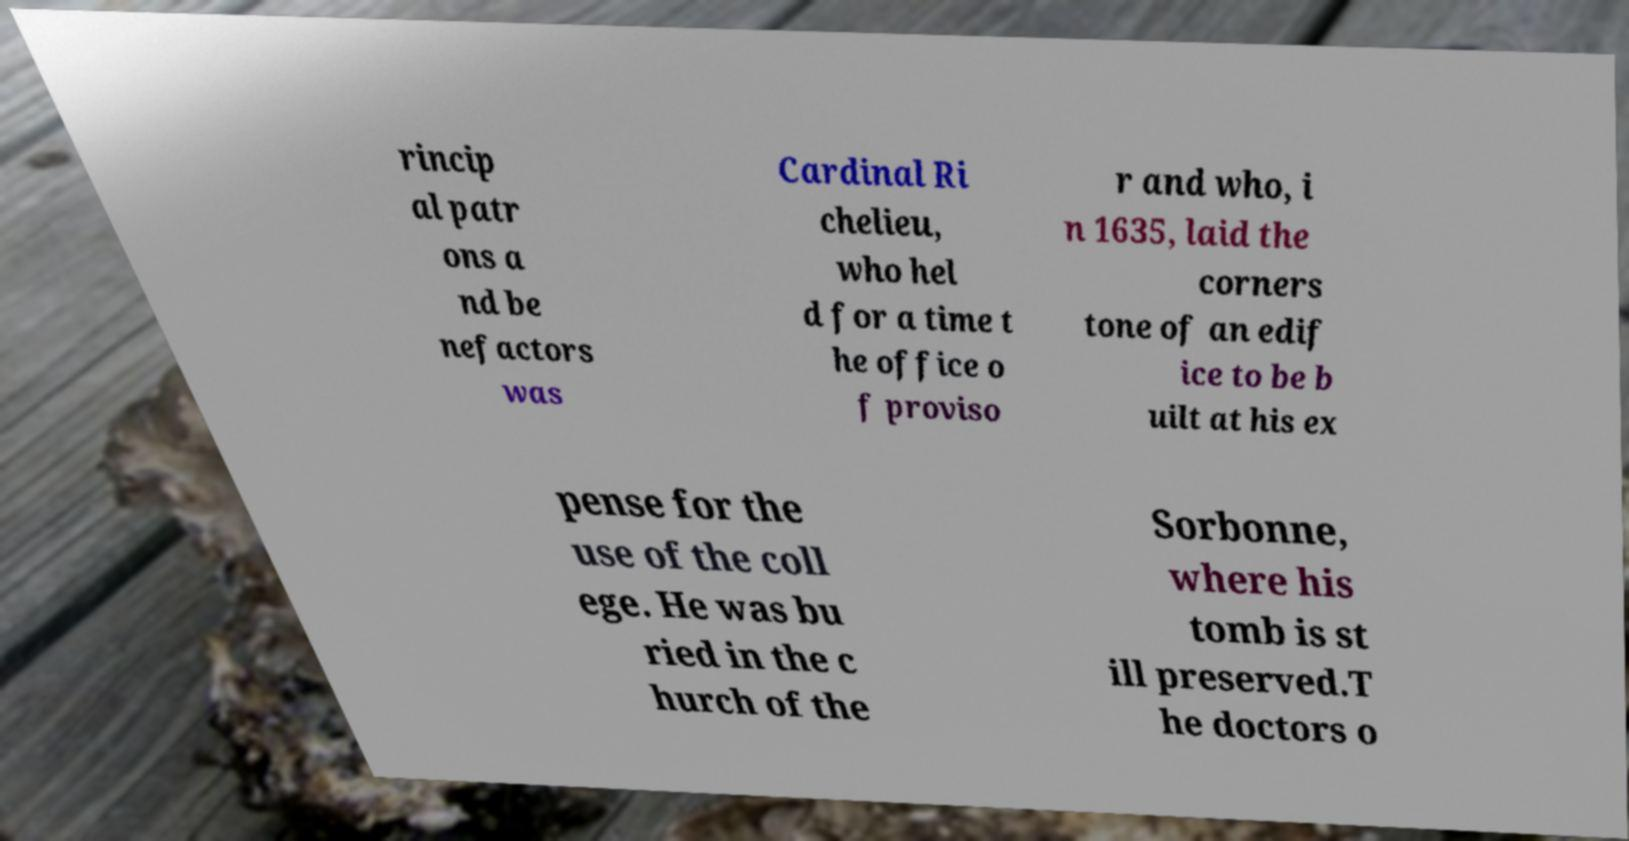Could you assist in decoding the text presented in this image and type it out clearly? rincip al patr ons a nd be nefactors was Cardinal Ri chelieu, who hel d for a time t he office o f proviso r and who, i n 1635, laid the corners tone of an edif ice to be b uilt at his ex pense for the use of the coll ege. He was bu ried in the c hurch of the Sorbonne, where his tomb is st ill preserved.T he doctors o 